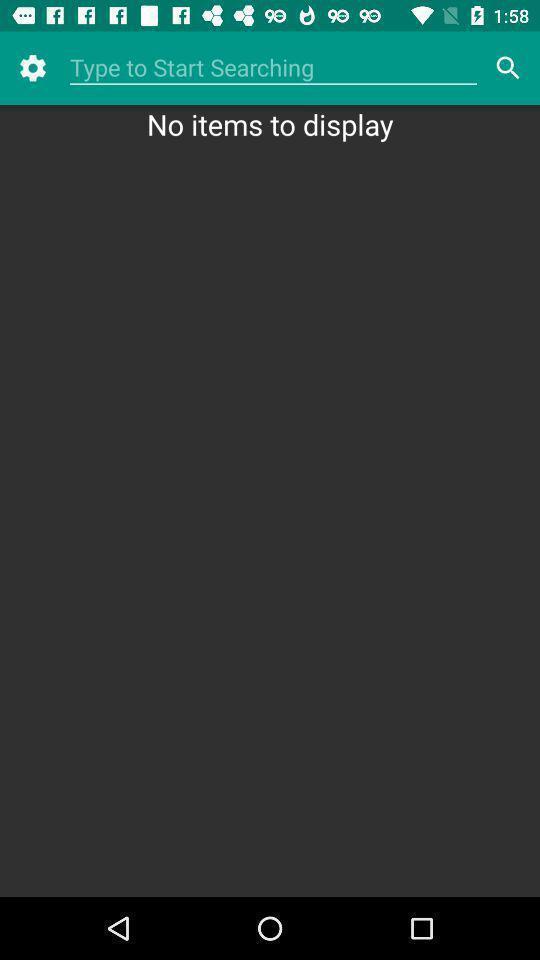Tell me about the visual elements in this screen capture. Search bar option page of a settings. 